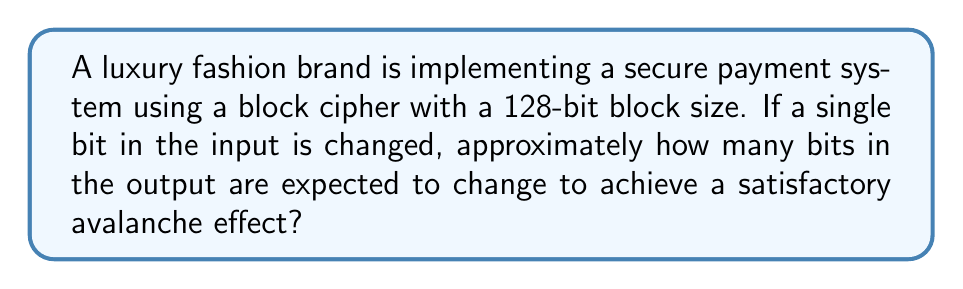Provide a solution to this math problem. To analyze the avalanche effect in a block cipher for secure payment systems, we need to consider the following steps:

1. Understand the avalanche effect:
   The avalanche effect is a desirable property in cryptographic algorithms where a small change in the input (such as flipping a single bit) should result in a significant change in the output.

2. Ideal avalanche effect:
   In an ideal scenario, each output bit should have a 50% probability of changing when a single input bit is flipped. This ensures that the relationship between the input and output is complex and unpredictable.

3. Calculate the expected number of changed bits:
   For a 128-bit block size, we can calculate the expected number of changed bits as follows:

   $$\text{Expected number of changed bits} = \text{Block size} \times \text{Probability of change}$$
   $$= 128 \times 0.5 = 64\text{ bits}$$

4. Assess the avalanche effect:
   A satisfactory avalanche effect is typically achieved when approximately half of the output bits change. In this case, 64 bits changing out of 128 bits represents a 50% change, which is considered satisfactory.

5. Relevance to secure payment systems:
   For a luxury fashion brand's payment system, a strong avalanche effect ensures that small changes in transaction data (e.g., a slight modification in the price or customer information) result in significantly different encrypted outputs. This property enhances the security of the payment system by making it resistant to various cryptographic attacks.
Answer: 64 bits 